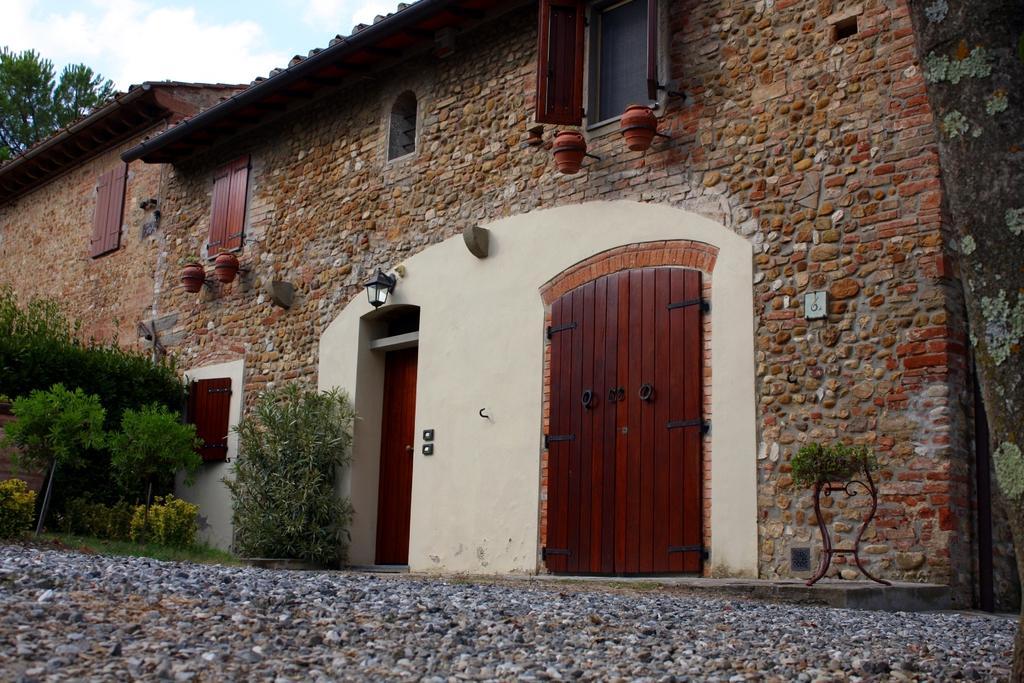Can you describe this image briefly? In this image I can see a building with stone and brick walls and wooden windows and doors and some plants on the left side of the image and stone way at the bottom of the image.  